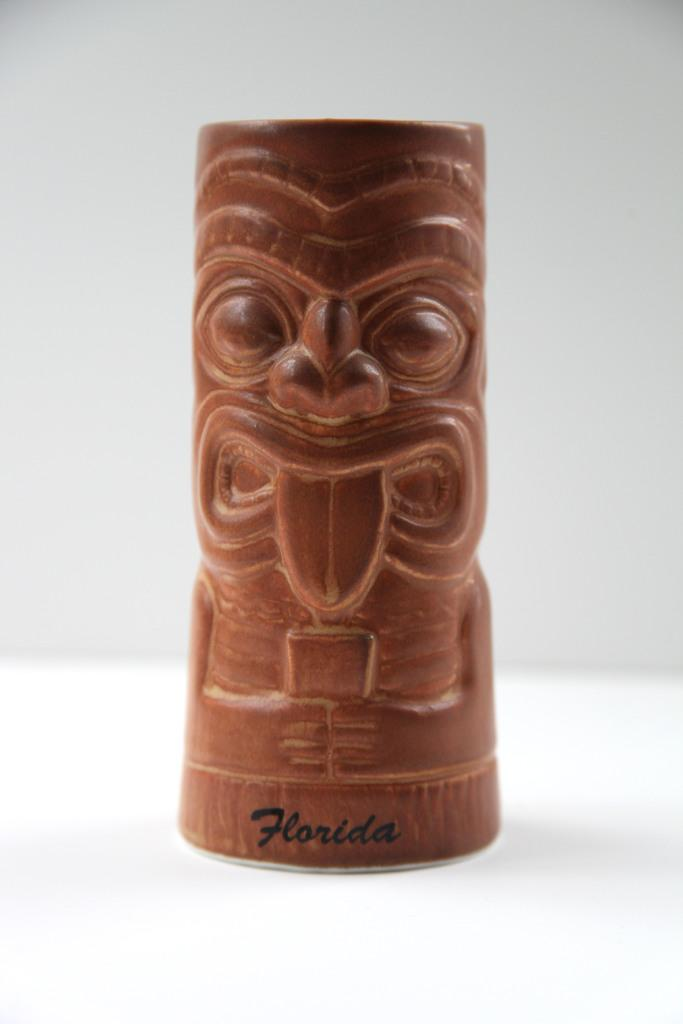What type of object is the main subject of the image? There is a wooden sculpture in the image. Is there any text associated with the image? Yes, there is text written at the bottom of the image. What color is the background of the image? The background of the image is white. What type of metal gate can be seen in the image? There is no metal gate present in the image; it features a wooden sculpture and text on a white background. Can you tell me how many kittens are playing with the wooden sculpture in the image? There are no kittens present in the image; it only features a wooden sculpture and text on a white background. 